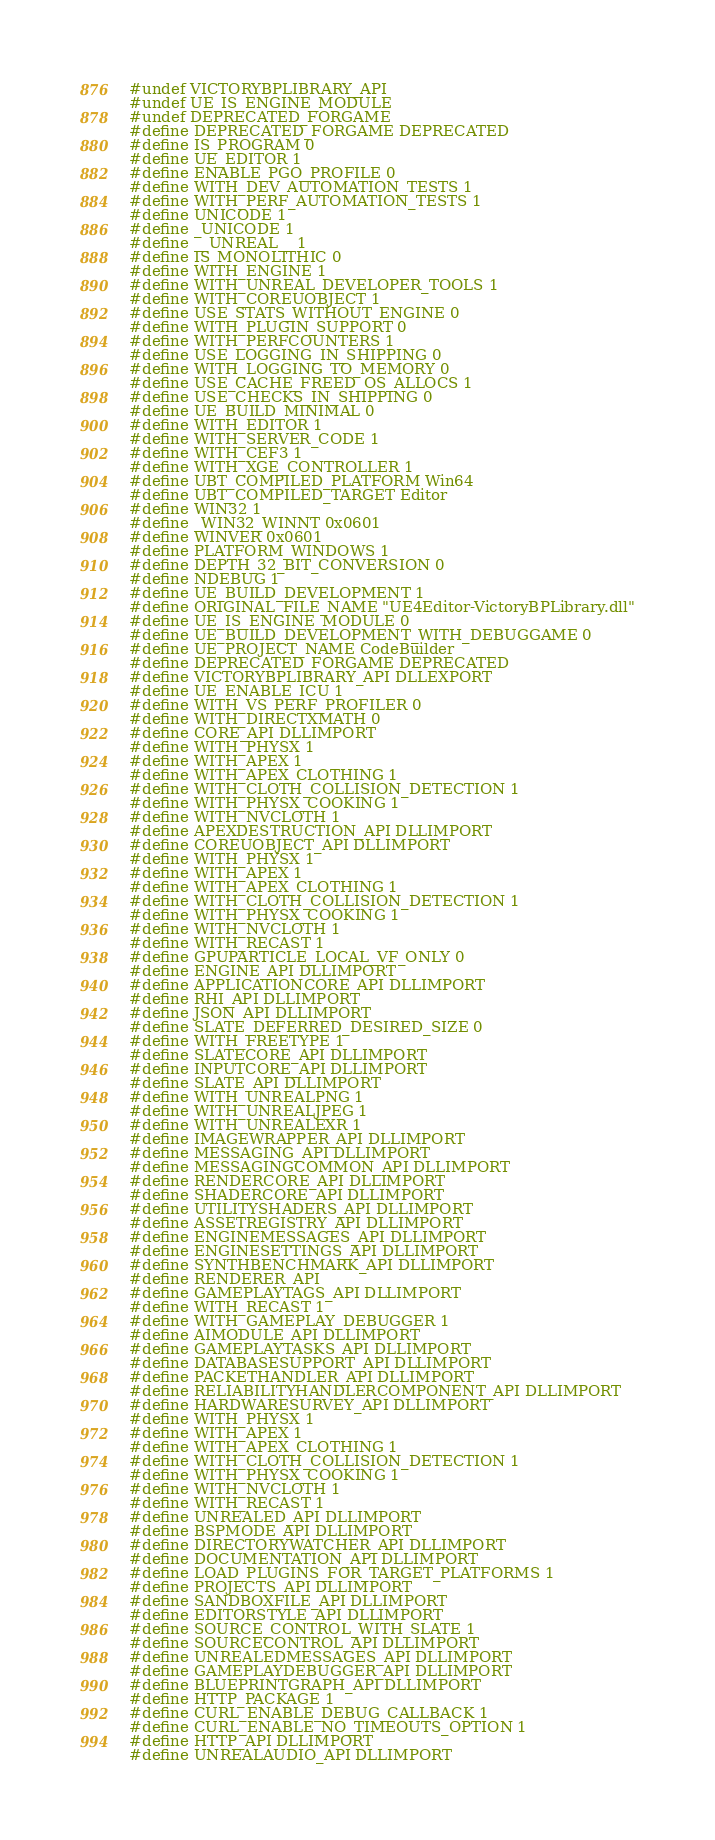<code> <loc_0><loc_0><loc_500><loc_500><_C_>#undef VICTORYBPLIBRARY_API
#undef UE_IS_ENGINE_MODULE
#undef DEPRECATED_FORGAME
#define DEPRECATED_FORGAME DEPRECATED
#define IS_PROGRAM 0
#define UE_EDITOR 1
#define ENABLE_PGO_PROFILE 0
#define WITH_DEV_AUTOMATION_TESTS 1
#define WITH_PERF_AUTOMATION_TESTS 1
#define UNICODE 1
#define _UNICODE 1
#define __UNREAL__ 1
#define IS_MONOLITHIC 0
#define WITH_ENGINE 1
#define WITH_UNREAL_DEVELOPER_TOOLS 1
#define WITH_COREUOBJECT 1
#define USE_STATS_WITHOUT_ENGINE 0
#define WITH_PLUGIN_SUPPORT 0
#define WITH_PERFCOUNTERS 1
#define USE_LOGGING_IN_SHIPPING 0
#define WITH_LOGGING_TO_MEMORY 0
#define USE_CACHE_FREED_OS_ALLOCS 1
#define USE_CHECKS_IN_SHIPPING 0
#define UE_BUILD_MINIMAL 0
#define WITH_EDITOR 1
#define WITH_SERVER_CODE 1
#define WITH_CEF3 1
#define WITH_XGE_CONTROLLER 1
#define UBT_COMPILED_PLATFORM Win64
#define UBT_COMPILED_TARGET Editor
#define WIN32 1
#define _WIN32_WINNT 0x0601
#define WINVER 0x0601
#define PLATFORM_WINDOWS 1
#define DEPTH_32_BIT_CONVERSION 0
#define NDEBUG 1
#define UE_BUILD_DEVELOPMENT 1
#define ORIGINAL_FILE_NAME "UE4Editor-VictoryBPLibrary.dll"
#define UE_IS_ENGINE_MODULE 0
#define UE_BUILD_DEVELOPMENT_WITH_DEBUGGAME 0
#define UE_PROJECT_NAME CodeBuilder
#define DEPRECATED_FORGAME DEPRECATED
#define VICTORYBPLIBRARY_API DLLEXPORT
#define UE_ENABLE_ICU 1
#define WITH_VS_PERF_PROFILER 0
#define WITH_DIRECTXMATH 0
#define CORE_API DLLIMPORT
#define WITH_PHYSX 1
#define WITH_APEX 1
#define WITH_APEX_CLOTHING 1
#define WITH_CLOTH_COLLISION_DETECTION 1
#define WITH_PHYSX_COOKING 1
#define WITH_NVCLOTH 1
#define APEXDESTRUCTION_API DLLIMPORT
#define COREUOBJECT_API DLLIMPORT
#define WITH_PHYSX 1
#define WITH_APEX 1
#define WITH_APEX_CLOTHING 1
#define WITH_CLOTH_COLLISION_DETECTION 1
#define WITH_PHYSX_COOKING 1
#define WITH_NVCLOTH 1
#define WITH_RECAST 1
#define GPUPARTICLE_LOCAL_VF_ONLY 0
#define ENGINE_API DLLIMPORT
#define APPLICATIONCORE_API DLLIMPORT
#define RHI_API DLLIMPORT
#define JSON_API DLLIMPORT
#define SLATE_DEFERRED_DESIRED_SIZE 0
#define WITH_FREETYPE 1
#define SLATECORE_API DLLIMPORT
#define INPUTCORE_API DLLIMPORT
#define SLATE_API DLLIMPORT
#define WITH_UNREALPNG 1
#define WITH_UNREALJPEG 1
#define WITH_UNREALEXR 1
#define IMAGEWRAPPER_API DLLIMPORT
#define MESSAGING_API DLLIMPORT
#define MESSAGINGCOMMON_API DLLIMPORT
#define RENDERCORE_API DLLIMPORT
#define SHADERCORE_API DLLIMPORT
#define UTILITYSHADERS_API DLLIMPORT
#define ASSETREGISTRY_API DLLIMPORT
#define ENGINEMESSAGES_API DLLIMPORT
#define ENGINESETTINGS_API DLLIMPORT
#define SYNTHBENCHMARK_API DLLIMPORT
#define RENDERER_API 
#define GAMEPLAYTAGS_API DLLIMPORT
#define WITH_RECAST 1
#define WITH_GAMEPLAY_DEBUGGER 1
#define AIMODULE_API DLLIMPORT
#define GAMEPLAYTASKS_API DLLIMPORT
#define DATABASESUPPORT_API DLLIMPORT
#define PACKETHANDLER_API DLLIMPORT
#define RELIABILITYHANDLERCOMPONENT_API DLLIMPORT
#define HARDWARESURVEY_API DLLIMPORT
#define WITH_PHYSX 1
#define WITH_APEX 1
#define WITH_APEX_CLOTHING 1
#define WITH_CLOTH_COLLISION_DETECTION 1
#define WITH_PHYSX_COOKING 1
#define WITH_NVCLOTH 1
#define WITH_RECAST 1
#define UNREALED_API DLLIMPORT
#define BSPMODE_API DLLIMPORT
#define DIRECTORYWATCHER_API DLLIMPORT
#define DOCUMENTATION_API DLLIMPORT
#define LOAD_PLUGINS_FOR_TARGET_PLATFORMS 1
#define PROJECTS_API DLLIMPORT
#define SANDBOXFILE_API DLLIMPORT
#define EDITORSTYLE_API DLLIMPORT
#define SOURCE_CONTROL_WITH_SLATE 1
#define SOURCECONTROL_API DLLIMPORT
#define UNREALEDMESSAGES_API DLLIMPORT
#define GAMEPLAYDEBUGGER_API DLLIMPORT
#define BLUEPRINTGRAPH_API DLLIMPORT
#define HTTP_PACKAGE 1
#define CURL_ENABLE_DEBUG_CALLBACK 1
#define CURL_ENABLE_NO_TIMEOUTS_OPTION 1
#define HTTP_API DLLIMPORT
#define UNREALAUDIO_API DLLIMPORT</code> 